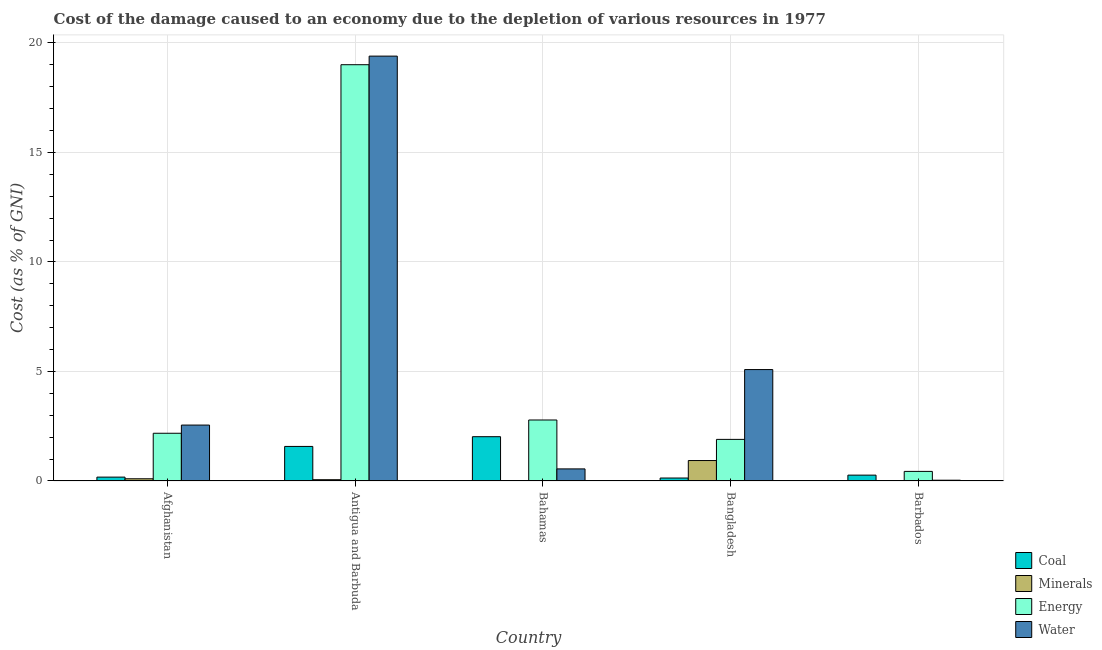How many different coloured bars are there?
Ensure brevity in your answer.  4. How many groups of bars are there?
Ensure brevity in your answer.  5. Are the number of bars on each tick of the X-axis equal?
Give a very brief answer. Yes. What is the label of the 1st group of bars from the left?
Offer a very short reply. Afghanistan. In how many cases, is the number of bars for a given country not equal to the number of legend labels?
Offer a terse response. 0. What is the cost of damage due to depletion of minerals in Bangladesh?
Your answer should be very brief. 0.93. Across all countries, what is the maximum cost of damage due to depletion of water?
Offer a very short reply. 19.39. Across all countries, what is the minimum cost of damage due to depletion of energy?
Your response must be concise. 0.44. In which country was the cost of damage due to depletion of minerals maximum?
Ensure brevity in your answer.  Bangladesh. In which country was the cost of damage due to depletion of water minimum?
Offer a terse response. Barbados. What is the total cost of damage due to depletion of energy in the graph?
Give a very brief answer. 26.3. What is the difference between the cost of damage due to depletion of water in Antigua and Barbuda and that in Barbados?
Offer a very short reply. 19.36. What is the difference between the cost of damage due to depletion of minerals in Antigua and Barbuda and the cost of damage due to depletion of energy in Barbados?
Give a very brief answer. -0.38. What is the average cost of damage due to depletion of water per country?
Keep it short and to the point. 5.52. What is the difference between the cost of damage due to depletion of coal and cost of damage due to depletion of energy in Bangladesh?
Provide a short and direct response. -1.76. What is the ratio of the cost of damage due to depletion of energy in Afghanistan to that in Bangladesh?
Keep it short and to the point. 1.15. Is the difference between the cost of damage due to depletion of energy in Antigua and Barbuda and Bahamas greater than the difference between the cost of damage due to depletion of coal in Antigua and Barbuda and Bahamas?
Your answer should be compact. Yes. What is the difference between the highest and the second highest cost of damage due to depletion of water?
Ensure brevity in your answer.  14.31. What is the difference between the highest and the lowest cost of damage due to depletion of water?
Provide a short and direct response. 19.36. In how many countries, is the cost of damage due to depletion of water greater than the average cost of damage due to depletion of water taken over all countries?
Offer a very short reply. 1. Is the sum of the cost of damage due to depletion of water in Bahamas and Bangladesh greater than the maximum cost of damage due to depletion of energy across all countries?
Your response must be concise. No. Is it the case that in every country, the sum of the cost of damage due to depletion of coal and cost of damage due to depletion of water is greater than the sum of cost of damage due to depletion of minerals and cost of damage due to depletion of energy?
Your answer should be compact. No. What does the 1st bar from the left in Antigua and Barbuda represents?
Provide a succinct answer. Coal. What does the 4th bar from the right in Afghanistan represents?
Offer a very short reply. Coal. How many bars are there?
Provide a short and direct response. 20. Are all the bars in the graph horizontal?
Your answer should be compact. No. What is the difference between two consecutive major ticks on the Y-axis?
Provide a succinct answer. 5. Are the values on the major ticks of Y-axis written in scientific E-notation?
Ensure brevity in your answer.  No. Does the graph contain grids?
Give a very brief answer. Yes. How many legend labels are there?
Provide a succinct answer. 4. What is the title of the graph?
Provide a succinct answer. Cost of the damage caused to an economy due to the depletion of various resources in 1977 . What is the label or title of the Y-axis?
Give a very brief answer. Cost (as % of GNI). What is the Cost (as % of GNI) of Coal in Afghanistan?
Provide a succinct answer. 0.18. What is the Cost (as % of GNI) of Minerals in Afghanistan?
Make the answer very short. 0.1. What is the Cost (as % of GNI) in Energy in Afghanistan?
Make the answer very short. 2.18. What is the Cost (as % of GNI) in Water in Afghanistan?
Your response must be concise. 2.55. What is the Cost (as % of GNI) of Coal in Antigua and Barbuda?
Give a very brief answer. 1.58. What is the Cost (as % of GNI) in Minerals in Antigua and Barbuda?
Your answer should be very brief. 0.06. What is the Cost (as % of GNI) of Energy in Antigua and Barbuda?
Give a very brief answer. 19. What is the Cost (as % of GNI) in Water in Antigua and Barbuda?
Give a very brief answer. 19.39. What is the Cost (as % of GNI) in Coal in Bahamas?
Keep it short and to the point. 2.02. What is the Cost (as % of GNI) in Minerals in Bahamas?
Make the answer very short. 0.02. What is the Cost (as % of GNI) of Energy in Bahamas?
Ensure brevity in your answer.  2.78. What is the Cost (as % of GNI) of Water in Bahamas?
Provide a succinct answer. 0.55. What is the Cost (as % of GNI) in Coal in Bangladesh?
Provide a succinct answer. 0.14. What is the Cost (as % of GNI) of Minerals in Bangladesh?
Offer a terse response. 0.93. What is the Cost (as % of GNI) of Energy in Bangladesh?
Your answer should be compact. 1.9. What is the Cost (as % of GNI) of Water in Bangladesh?
Make the answer very short. 5.09. What is the Cost (as % of GNI) in Coal in Barbados?
Make the answer very short. 0.27. What is the Cost (as % of GNI) in Minerals in Barbados?
Give a very brief answer. 0. What is the Cost (as % of GNI) of Energy in Barbados?
Offer a terse response. 0.44. What is the Cost (as % of GNI) of Water in Barbados?
Keep it short and to the point. 0.04. Across all countries, what is the maximum Cost (as % of GNI) of Coal?
Your answer should be compact. 2.02. Across all countries, what is the maximum Cost (as % of GNI) in Minerals?
Ensure brevity in your answer.  0.93. Across all countries, what is the maximum Cost (as % of GNI) of Energy?
Ensure brevity in your answer.  19. Across all countries, what is the maximum Cost (as % of GNI) of Water?
Offer a terse response. 19.39. Across all countries, what is the minimum Cost (as % of GNI) of Coal?
Provide a short and direct response. 0.14. Across all countries, what is the minimum Cost (as % of GNI) in Minerals?
Your answer should be very brief. 0. Across all countries, what is the minimum Cost (as % of GNI) in Energy?
Offer a very short reply. 0.44. Across all countries, what is the minimum Cost (as % of GNI) in Water?
Your response must be concise. 0.04. What is the total Cost (as % of GNI) of Coal in the graph?
Your answer should be compact. 4.18. What is the total Cost (as % of GNI) of Minerals in the graph?
Give a very brief answer. 1.12. What is the total Cost (as % of GNI) in Energy in the graph?
Your answer should be compact. 26.3. What is the total Cost (as % of GNI) in Water in the graph?
Give a very brief answer. 27.62. What is the difference between the Cost (as % of GNI) in Coal in Afghanistan and that in Antigua and Barbuda?
Provide a succinct answer. -1.4. What is the difference between the Cost (as % of GNI) of Minerals in Afghanistan and that in Antigua and Barbuda?
Offer a very short reply. 0.04. What is the difference between the Cost (as % of GNI) of Energy in Afghanistan and that in Antigua and Barbuda?
Your answer should be compact. -16.82. What is the difference between the Cost (as % of GNI) in Water in Afghanistan and that in Antigua and Barbuda?
Keep it short and to the point. -16.84. What is the difference between the Cost (as % of GNI) of Coal in Afghanistan and that in Bahamas?
Give a very brief answer. -1.84. What is the difference between the Cost (as % of GNI) of Minerals in Afghanistan and that in Bahamas?
Keep it short and to the point. 0.08. What is the difference between the Cost (as % of GNI) of Energy in Afghanistan and that in Bahamas?
Offer a terse response. -0.61. What is the difference between the Cost (as % of GNI) of Water in Afghanistan and that in Bahamas?
Give a very brief answer. 2. What is the difference between the Cost (as % of GNI) in Coal in Afghanistan and that in Bangladesh?
Your answer should be very brief. 0.04. What is the difference between the Cost (as % of GNI) of Minerals in Afghanistan and that in Bangladesh?
Offer a very short reply. -0.83. What is the difference between the Cost (as % of GNI) of Energy in Afghanistan and that in Bangladesh?
Provide a short and direct response. 0.28. What is the difference between the Cost (as % of GNI) of Water in Afghanistan and that in Bangladesh?
Offer a very short reply. -2.53. What is the difference between the Cost (as % of GNI) of Coal in Afghanistan and that in Barbados?
Provide a succinct answer. -0.09. What is the difference between the Cost (as % of GNI) of Minerals in Afghanistan and that in Barbados?
Provide a short and direct response. 0.1. What is the difference between the Cost (as % of GNI) of Energy in Afghanistan and that in Barbados?
Provide a succinct answer. 1.74. What is the difference between the Cost (as % of GNI) of Water in Afghanistan and that in Barbados?
Provide a succinct answer. 2.52. What is the difference between the Cost (as % of GNI) of Coal in Antigua and Barbuda and that in Bahamas?
Your answer should be compact. -0.44. What is the difference between the Cost (as % of GNI) in Minerals in Antigua and Barbuda and that in Bahamas?
Your answer should be compact. 0.04. What is the difference between the Cost (as % of GNI) of Energy in Antigua and Barbuda and that in Bahamas?
Make the answer very short. 16.22. What is the difference between the Cost (as % of GNI) in Water in Antigua and Barbuda and that in Bahamas?
Ensure brevity in your answer.  18.84. What is the difference between the Cost (as % of GNI) of Coal in Antigua and Barbuda and that in Bangladesh?
Offer a very short reply. 1.44. What is the difference between the Cost (as % of GNI) of Minerals in Antigua and Barbuda and that in Bangladesh?
Offer a very short reply. -0.87. What is the difference between the Cost (as % of GNI) in Energy in Antigua and Barbuda and that in Bangladesh?
Your response must be concise. 17.1. What is the difference between the Cost (as % of GNI) of Water in Antigua and Barbuda and that in Bangladesh?
Keep it short and to the point. 14.31. What is the difference between the Cost (as % of GNI) in Coal in Antigua and Barbuda and that in Barbados?
Your answer should be very brief. 1.31. What is the difference between the Cost (as % of GNI) in Minerals in Antigua and Barbuda and that in Barbados?
Offer a terse response. 0.05. What is the difference between the Cost (as % of GNI) in Energy in Antigua and Barbuda and that in Barbados?
Provide a short and direct response. 18.56. What is the difference between the Cost (as % of GNI) of Water in Antigua and Barbuda and that in Barbados?
Your answer should be very brief. 19.36. What is the difference between the Cost (as % of GNI) of Coal in Bahamas and that in Bangladesh?
Provide a succinct answer. 1.89. What is the difference between the Cost (as % of GNI) in Minerals in Bahamas and that in Bangladesh?
Provide a short and direct response. -0.91. What is the difference between the Cost (as % of GNI) of Energy in Bahamas and that in Bangladesh?
Offer a very short reply. 0.89. What is the difference between the Cost (as % of GNI) in Water in Bahamas and that in Bangladesh?
Provide a succinct answer. -4.53. What is the difference between the Cost (as % of GNI) in Coal in Bahamas and that in Barbados?
Keep it short and to the point. 1.75. What is the difference between the Cost (as % of GNI) of Minerals in Bahamas and that in Barbados?
Give a very brief answer. 0.02. What is the difference between the Cost (as % of GNI) in Energy in Bahamas and that in Barbados?
Give a very brief answer. 2.35. What is the difference between the Cost (as % of GNI) in Water in Bahamas and that in Barbados?
Offer a very short reply. 0.52. What is the difference between the Cost (as % of GNI) in Coal in Bangladesh and that in Barbados?
Make the answer very short. -0.13. What is the difference between the Cost (as % of GNI) of Minerals in Bangladesh and that in Barbados?
Your answer should be compact. 0.93. What is the difference between the Cost (as % of GNI) in Energy in Bangladesh and that in Barbados?
Your response must be concise. 1.46. What is the difference between the Cost (as % of GNI) of Water in Bangladesh and that in Barbados?
Offer a very short reply. 5.05. What is the difference between the Cost (as % of GNI) in Coal in Afghanistan and the Cost (as % of GNI) in Minerals in Antigua and Barbuda?
Give a very brief answer. 0.12. What is the difference between the Cost (as % of GNI) of Coal in Afghanistan and the Cost (as % of GNI) of Energy in Antigua and Barbuda?
Make the answer very short. -18.83. What is the difference between the Cost (as % of GNI) of Coal in Afghanistan and the Cost (as % of GNI) of Water in Antigua and Barbuda?
Offer a very short reply. -19.22. What is the difference between the Cost (as % of GNI) of Minerals in Afghanistan and the Cost (as % of GNI) of Energy in Antigua and Barbuda?
Provide a short and direct response. -18.9. What is the difference between the Cost (as % of GNI) in Minerals in Afghanistan and the Cost (as % of GNI) in Water in Antigua and Barbuda?
Offer a terse response. -19.29. What is the difference between the Cost (as % of GNI) in Energy in Afghanistan and the Cost (as % of GNI) in Water in Antigua and Barbuda?
Give a very brief answer. -17.21. What is the difference between the Cost (as % of GNI) of Coal in Afghanistan and the Cost (as % of GNI) of Minerals in Bahamas?
Make the answer very short. 0.16. What is the difference between the Cost (as % of GNI) of Coal in Afghanistan and the Cost (as % of GNI) of Energy in Bahamas?
Keep it short and to the point. -2.61. What is the difference between the Cost (as % of GNI) of Coal in Afghanistan and the Cost (as % of GNI) of Water in Bahamas?
Keep it short and to the point. -0.37. What is the difference between the Cost (as % of GNI) of Minerals in Afghanistan and the Cost (as % of GNI) of Energy in Bahamas?
Your answer should be very brief. -2.68. What is the difference between the Cost (as % of GNI) in Minerals in Afghanistan and the Cost (as % of GNI) in Water in Bahamas?
Give a very brief answer. -0.45. What is the difference between the Cost (as % of GNI) in Energy in Afghanistan and the Cost (as % of GNI) in Water in Bahamas?
Provide a short and direct response. 1.63. What is the difference between the Cost (as % of GNI) in Coal in Afghanistan and the Cost (as % of GNI) in Minerals in Bangladesh?
Give a very brief answer. -0.76. What is the difference between the Cost (as % of GNI) in Coal in Afghanistan and the Cost (as % of GNI) in Energy in Bangladesh?
Your response must be concise. -1.72. What is the difference between the Cost (as % of GNI) of Coal in Afghanistan and the Cost (as % of GNI) of Water in Bangladesh?
Your response must be concise. -4.91. What is the difference between the Cost (as % of GNI) in Minerals in Afghanistan and the Cost (as % of GNI) in Energy in Bangladesh?
Your answer should be very brief. -1.8. What is the difference between the Cost (as % of GNI) in Minerals in Afghanistan and the Cost (as % of GNI) in Water in Bangladesh?
Keep it short and to the point. -4.98. What is the difference between the Cost (as % of GNI) in Energy in Afghanistan and the Cost (as % of GNI) in Water in Bangladesh?
Your answer should be compact. -2.91. What is the difference between the Cost (as % of GNI) of Coal in Afghanistan and the Cost (as % of GNI) of Minerals in Barbados?
Provide a succinct answer. 0.17. What is the difference between the Cost (as % of GNI) in Coal in Afghanistan and the Cost (as % of GNI) in Energy in Barbados?
Provide a succinct answer. -0.26. What is the difference between the Cost (as % of GNI) of Coal in Afghanistan and the Cost (as % of GNI) of Water in Barbados?
Your answer should be very brief. 0.14. What is the difference between the Cost (as % of GNI) of Minerals in Afghanistan and the Cost (as % of GNI) of Energy in Barbados?
Your answer should be compact. -0.34. What is the difference between the Cost (as % of GNI) of Minerals in Afghanistan and the Cost (as % of GNI) of Water in Barbados?
Keep it short and to the point. 0.07. What is the difference between the Cost (as % of GNI) in Energy in Afghanistan and the Cost (as % of GNI) in Water in Barbados?
Your answer should be very brief. 2.14. What is the difference between the Cost (as % of GNI) of Coal in Antigua and Barbuda and the Cost (as % of GNI) of Minerals in Bahamas?
Make the answer very short. 1.56. What is the difference between the Cost (as % of GNI) of Coal in Antigua and Barbuda and the Cost (as % of GNI) of Energy in Bahamas?
Ensure brevity in your answer.  -1.21. What is the difference between the Cost (as % of GNI) in Coal in Antigua and Barbuda and the Cost (as % of GNI) in Water in Bahamas?
Provide a succinct answer. 1.03. What is the difference between the Cost (as % of GNI) in Minerals in Antigua and Barbuda and the Cost (as % of GNI) in Energy in Bahamas?
Provide a short and direct response. -2.73. What is the difference between the Cost (as % of GNI) in Minerals in Antigua and Barbuda and the Cost (as % of GNI) in Water in Bahamas?
Your answer should be very brief. -0.49. What is the difference between the Cost (as % of GNI) in Energy in Antigua and Barbuda and the Cost (as % of GNI) in Water in Bahamas?
Provide a succinct answer. 18.45. What is the difference between the Cost (as % of GNI) in Coal in Antigua and Barbuda and the Cost (as % of GNI) in Minerals in Bangladesh?
Provide a short and direct response. 0.64. What is the difference between the Cost (as % of GNI) in Coal in Antigua and Barbuda and the Cost (as % of GNI) in Energy in Bangladesh?
Provide a short and direct response. -0.32. What is the difference between the Cost (as % of GNI) in Coal in Antigua and Barbuda and the Cost (as % of GNI) in Water in Bangladesh?
Provide a short and direct response. -3.51. What is the difference between the Cost (as % of GNI) of Minerals in Antigua and Barbuda and the Cost (as % of GNI) of Energy in Bangladesh?
Your response must be concise. -1.84. What is the difference between the Cost (as % of GNI) in Minerals in Antigua and Barbuda and the Cost (as % of GNI) in Water in Bangladesh?
Provide a succinct answer. -5.03. What is the difference between the Cost (as % of GNI) of Energy in Antigua and Barbuda and the Cost (as % of GNI) of Water in Bangladesh?
Give a very brief answer. 13.92. What is the difference between the Cost (as % of GNI) in Coal in Antigua and Barbuda and the Cost (as % of GNI) in Minerals in Barbados?
Your answer should be compact. 1.57. What is the difference between the Cost (as % of GNI) of Coal in Antigua and Barbuda and the Cost (as % of GNI) of Energy in Barbados?
Your response must be concise. 1.14. What is the difference between the Cost (as % of GNI) of Coal in Antigua and Barbuda and the Cost (as % of GNI) of Water in Barbados?
Your answer should be very brief. 1.54. What is the difference between the Cost (as % of GNI) of Minerals in Antigua and Barbuda and the Cost (as % of GNI) of Energy in Barbados?
Keep it short and to the point. -0.38. What is the difference between the Cost (as % of GNI) of Minerals in Antigua and Barbuda and the Cost (as % of GNI) of Water in Barbados?
Give a very brief answer. 0.02. What is the difference between the Cost (as % of GNI) of Energy in Antigua and Barbuda and the Cost (as % of GNI) of Water in Barbados?
Give a very brief answer. 18.97. What is the difference between the Cost (as % of GNI) in Coal in Bahamas and the Cost (as % of GNI) in Minerals in Bangladesh?
Provide a short and direct response. 1.09. What is the difference between the Cost (as % of GNI) in Coal in Bahamas and the Cost (as % of GNI) in Energy in Bangladesh?
Ensure brevity in your answer.  0.12. What is the difference between the Cost (as % of GNI) of Coal in Bahamas and the Cost (as % of GNI) of Water in Bangladesh?
Your answer should be compact. -3.06. What is the difference between the Cost (as % of GNI) of Minerals in Bahamas and the Cost (as % of GNI) of Energy in Bangladesh?
Provide a succinct answer. -1.88. What is the difference between the Cost (as % of GNI) of Minerals in Bahamas and the Cost (as % of GNI) of Water in Bangladesh?
Provide a short and direct response. -5.07. What is the difference between the Cost (as % of GNI) of Energy in Bahamas and the Cost (as % of GNI) of Water in Bangladesh?
Your answer should be compact. -2.3. What is the difference between the Cost (as % of GNI) in Coal in Bahamas and the Cost (as % of GNI) in Minerals in Barbados?
Keep it short and to the point. 2.02. What is the difference between the Cost (as % of GNI) in Coal in Bahamas and the Cost (as % of GNI) in Energy in Barbados?
Your response must be concise. 1.58. What is the difference between the Cost (as % of GNI) of Coal in Bahamas and the Cost (as % of GNI) of Water in Barbados?
Your response must be concise. 1.99. What is the difference between the Cost (as % of GNI) in Minerals in Bahamas and the Cost (as % of GNI) in Energy in Barbados?
Provide a short and direct response. -0.42. What is the difference between the Cost (as % of GNI) of Minerals in Bahamas and the Cost (as % of GNI) of Water in Barbados?
Offer a very short reply. -0.01. What is the difference between the Cost (as % of GNI) in Energy in Bahamas and the Cost (as % of GNI) in Water in Barbados?
Provide a succinct answer. 2.75. What is the difference between the Cost (as % of GNI) of Coal in Bangladesh and the Cost (as % of GNI) of Minerals in Barbados?
Offer a terse response. 0.13. What is the difference between the Cost (as % of GNI) of Coal in Bangladesh and the Cost (as % of GNI) of Energy in Barbados?
Your response must be concise. -0.3. What is the difference between the Cost (as % of GNI) in Coal in Bangladesh and the Cost (as % of GNI) in Water in Barbados?
Make the answer very short. 0.1. What is the difference between the Cost (as % of GNI) in Minerals in Bangladesh and the Cost (as % of GNI) in Energy in Barbados?
Your answer should be very brief. 0.5. What is the difference between the Cost (as % of GNI) of Minerals in Bangladesh and the Cost (as % of GNI) of Water in Barbados?
Provide a short and direct response. 0.9. What is the difference between the Cost (as % of GNI) of Energy in Bangladesh and the Cost (as % of GNI) of Water in Barbados?
Offer a very short reply. 1.86. What is the average Cost (as % of GNI) of Coal per country?
Your response must be concise. 0.84. What is the average Cost (as % of GNI) in Minerals per country?
Keep it short and to the point. 0.22. What is the average Cost (as % of GNI) in Energy per country?
Provide a succinct answer. 5.26. What is the average Cost (as % of GNI) in Water per country?
Ensure brevity in your answer.  5.52. What is the difference between the Cost (as % of GNI) in Coal and Cost (as % of GNI) in Minerals in Afghanistan?
Keep it short and to the point. 0.08. What is the difference between the Cost (as % of GNI) of Coal and Cost (as % of GNI) of Energy in Afghanistan?
Keep it short and to the point. -2. What is the difference between the Cost (as % of GNI) of Coal and Cost (as % of GNI) of Water in Afghanistan?
Ensure brevity in your answer.  -2.38. What is the difference between the Cost (as % of GNI) of Minerals and Cost (as % of GNI) of Energy in Afghanistan?
Your answer should be very brief. -2.08. What is the difference between the Cost (as % of GNI) in Minerals and Cost (as % of GNI) in Water in Afghanistan?
Make the answer very short. -2.45. What is the difference between the Cost (as % of GNI) of Energy and Cost (as % of GNI) of Water in Afghanistan?
Make the answer very short. -0.37. What is the difference between the Cost (as % of GNI) of Coal and Cost (as % of GNI) of Minerals in Antigua and Barbuda?
Offer a very short reply. 1.52. What is the difference between the Cost (as % of GNI) in Coal and Cost (as % of GNI) in Energy in Antigua and Barbuda?
Offer a very short reply. -17.42. What is the difference between the Cost (as % of GNI) in Coal and Cost (as % of GNI) in Water in Antigua and Barbuda?
Provide a short and direct response. -17.82. What is the difference between the Cost (as % of GNI) in Minerals and Cost (as % of GNI) in Energy in Antigua and Barbuda?
Keep it short and to the point. -18.94. What is the difference between the Cost (as % of GNI) of Minerals and Cost (as % of GNI) of Water in Antigua and Barbuda?
Make the answer very short. -19.34. What is the difference between the Cost (as % of GNI) in Energy and Cost (as % of GNI) in Water in Antigua and Barbuda?
Your answer should be very brief. -0.39. What is the difference between the Cost (as % of GNI) in Coal and Cost (as % of GNI) in Minerals in Bahamas?
Your response must be concise. 2. What is the difference between the Cost (as % of GNI) of Coal and Cost (as % of GNI) of Energy in Bahamas?
Your answer should be very brief. -0.76. What is the difference between the Cost (as % of GNI) in Coal and Cost (as % of GNI) in Water in Bahamas?
Ensure brevity in your answer.  1.47. What is the difference between the Cost (as % of GNI) of Minerals and Cost (as % of GNI) of Energy in Bahamas?
Offer a very short reply. -2.76. What is the difference between the Cost (as % of GNI) of Minerals and Cost (as % of GNI) of Water in Bahamas?
Your answer should be compact. -0.53. What is the difference between the Cost (as % of GNI) in Energy and Cost (as % of GNI) in Water in Bahamas?
Make the answer very short. 2.23. What is the difference between the Cost (as % of GNI) in Coal and Cost (as % of GNI) in Minerals in Bangladesh?
Ensure brevity in your answer.  -0.8. What is the difference between the Cost (as % of GNI) of Coal and Cost (as % of GNI) of Energy in Bangladesh?
Give a very brief answer. -1.76. What is the difference between the Cost (as % of GNI) in Coal and Cost (as % of GNI) in Water in Bangladesh?
Your answer should be very brief. -4.95. What is the difference between the Cost (as % of GNI) of Minerals and Cost (as % of GNI) of Energy in Bangladesh?
Give a very brief answer. -0.97. What is the difference between the Cost (as % of GNI) of Minerals and Cost (as % of GNI) of Water in Bangladesh?
Offer a very short reply. -4.15. What is the difference between the Cost (as % of GNI) of Energy and Cost (as % of GNI) of Water in Bangladesh?
Your answer should be compact. -3.19. What is the difference between the Cost (as % of GNI) of Coal and Cost (as % of GNI) of Minerals in Barbados?
Give a very brief answer. 0.26. What is the difference between the Cost (as % of GNI) in Coal and Cost (as % of GNI) in Energy in Barbados?
Your response must be concise. -0.17. What is the difference between the Cost (as % of GNI) of Coal and Cost (as % of GNI) of Water in Barbados?
Give a very brief answer. 0.23. What is the difference between the Cost (as % of GNI) in Minerals and Cost (as % of GNI) in Energy in Barbados?
Ensure brevity in your answer.  -0.43. What is the difference between the Cost (as % of GNI) in Minerals and Cost (as % of GNI) in Water in Barbados?
Provide a succinct answer. -0.03. What is the difference between the Cost (as % of GNI) in Energy and Cost (as % of GNI) in Water in Barbados?
Make the answer very short. 0.4. What is the ratio of the Cost (as % of GNI) in Coal in Afghanistan to that in Antigua and Barbuda?
Provide a short and direct response. 0.11. What is the ratio of the Cost (as % of GNI) of Minerals in Afghanistan to that in Antigua and Barbuda?
Offer a very short reply. 1.73. What is the ratio of the Cost (as % of GNI) in Energy in Afghanistan to that in Antigua and Barbuda?
Your answer should be compact. 0.11. What is the ratio of the Cost (as % of GNI) in Water in Afghanistan to that in Antigua and Barbuda?
Offer a terse response. 0.13. What is the ratio of the Cost (as % of GNI) of Coal in Afghanistan to that in Bahamas?
Your answer should be compact. 0.09. What is the ratio of the Cost (as % of GNI) in Minerals in Afghanistan to that in Bahamas?
Give a very brief answer. 4.82. What is the ratio of the Cost (as % of GNI) of Energy in Afghanistan to that in Bahamas?
Provide a succinct answer. 0.78. What is the ratio of the Cost (as % of GNI) in Water in Afghanistan to that in Bahamas?
Provide a short and direct response. 4.63. What is the ratio of the Cost (as % of GNI) of Coal in Afghanistan to that in Bangladesh?
Your answer should be very brief. 1.31. What is the ratio of the Cost (as % of GNI) in Minerals in Afghanistan to that in Bangladesh?
Your answer should be very brief. 0.11. What is the ratio of the Cost (as % of GNI) of Energy in Afghanistan to that in Bangladesh?
Offer a terse response. 1.15. What is the ratio of the Cost (as % of GNI) in Water in Afghanistan to that in Bangladesh?
Give a very brief answer. 0.5. What is the ratio of the Cost (as % of GNI) in Coal in Afghanistan to that in Barbados?
Offer a terse response. 0.66. What is the ratio of the Cost (as % of GNI) of Minerals in Afghanistan to that in Barbados?
Keep it short and to the point. 25.7. What is the ratio of the Cost (as % of GNI) of Energy in Afghanistan to that in Barbados?
Give a very brief answer. 4.98. What is the ratio of the Cost (as % of GNI) of Water in Afghanistan to that in Barbados?
Make the answer very short. 72.16. What is the ratio of the Cost (as % of GNI) of Coal in Antigua and Barbuda to that in Bahamas?
Your response must be concise. 0.78. What is the ratio of the Cost (as % of GNI) in Minerals in Antigua and Barbuda to that in Bahamas?
Ensure brevity in your answer.  2.79. What is the ratio of the Cost (as % of GNI) of Energy in Antigua and Barbuda to that in Bahamas?
Your response must be concise. 6.82. What is the ratio of the Cost (as % of GNI) of Water in Antigua and Barbuda to that in Bahamas?
Keep it short and to the point. 35.15. What is the ratio of the Cost (as % of GNI) of Coal in Antigua and Barbuda to that in Bangladesh?
Give a very brief answer. 11.65. What is the ratio of the Cost (as % of GNI) of Minerals in Antigua and Barbuda to that in Bangladesh?
Your response must be concise. 0.06. What is the ratio of the Cost (as % of GNI) in Energy in Antigua and Barbuda to that in Bangladesh?
Your answer should be very brief. 10.01. What is the ratio of the Cost (as % of GNI) in Water in Antigua and Barbuda to that in Bangladesh?
Provide a succinct answer. 3.81. What is the ratio of the Cost (as % of GNI) in Coal in Antigua and Barbuda to that in Barbados?
Your response must be concise. 5.9. What is the ratio of the Cost (as % of GNI) of Minerals in Antigua and Barbuda to that in Barbados?
Keep it short and to the point. 14.84. What is the ratio of the Cost (as % of GNI) of Energy in Antigua and Barbuda to that in Barbados?
Ensure brevity in your answer.  43.4. What is the ratio of the Cost (as % of GNI) of Water in Antigua and Barbuda to that in Barbados?
Your answer should be very brief. 548.24. What is the ratio of the Cost (as % of GNI) of Coal in Bahamas to that in Bangladesh?
Ensure brevity in your answer.  14.94. What is the ratio of the Cost (as % of GNI) in Minerals in Bahamas to that in Bangladesh?
Offer a terse response. 0.02. What is the ratio of the Cost (as % of GNI) in Energy in Bahamas to that in Bangladesh?
Ensure brevity in your answer.  1.47. What is the ratio of the Cost (as % of GNI) in Water in Bahamas to that in Bangladesh?
Offer a terse response. 0.11. What is the ratio of the Cost (as % of GNI) in Coal in Bahamas to that in Barbados?
Offer a very short reply. 7.56. What is the ratio of the Cost (as % of GNI) in Minerals in Bahamas to that in Barbados?
Make the answer very short. 5.33. What is the ratio of the Cost (as % of GNI) of Energy in Bahamas to that in Barbados?
Provide a succinct answer. 6.36. What is the ratio of the Cost (as % of GNI) in Water in Bahamas to that in Barbados?
Your answer should be compact. 15.6. What is the ratio of the Cost (as % of GNI) of Coal in Bangladesh to that in Barbados?
Provide a short and direct response. 0.51. What is the ratio of the Cost (as % of GNI) of Minerals in Bangladesh to that in Barbados?
Your response must be concise. 236.61. What is the ratio of the Cost (as % of GNI) in Energy in Bangladesh to that in Barbados?
Provide a short and direct response. 4.34. What is the ratio of the Cost (as % of GNI) in Water in Bangladesh to that in Barbados?
Offer a very short reply. 143.78. What is the difference between the highest and the second highest Cost (as % of GNI) of Coal?
Give a very brief answer. 0.44. What is the difference between the highest and the second highest Cost (as % of GNI) in Minerals?
Give a very brief answer. 0.83. What is the difference between the highest and the second highest Cost (as % of GNI) of Energy?
Provide a succinct answer. 16.22. What is the difference between the highest and the second highest Cost (as % of GNI) in Water?
Ensure brevity in your answer.  14.31. What is the difference between the highest and the lowest Cost (as % of GNI) of Coal?
Ensure brevity in your answer.  1.89. What is the difference between the highest and the lowest Cost (as % of GNI) of Minerals?
Offer a terse response. 0.93. What is the difference between the highest and the lowest Cost (as % of GNI) of Energy?
Provide a succinct answer. 18.56. What is the difference between the highest and the lowest Cost (as % of GNI) in Water?
Your answer should be compact. 19.36. 